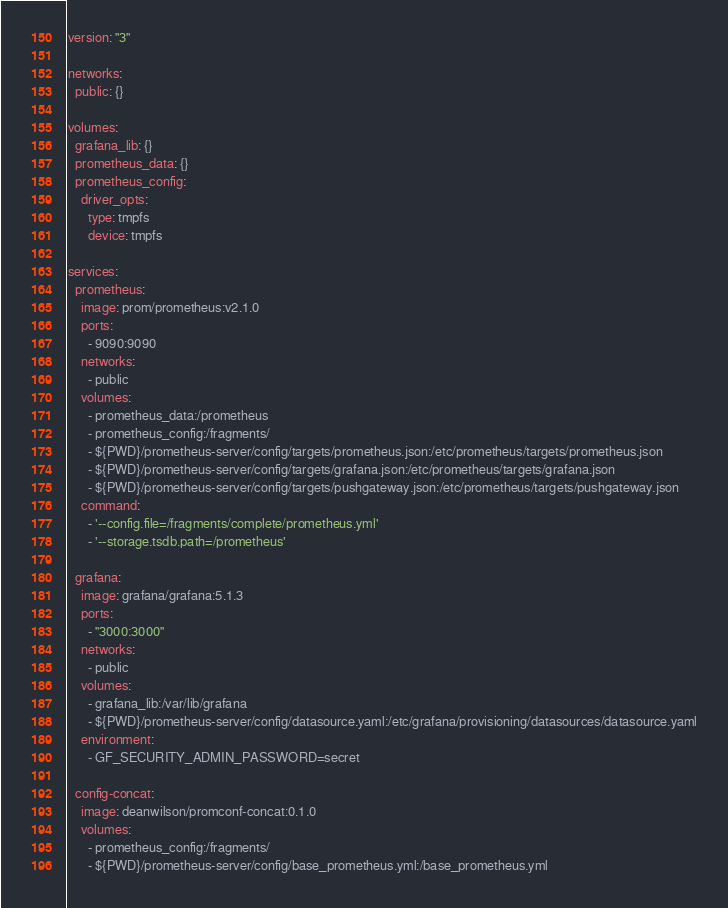<code> <loc_0><loc_0><loc_500><loc_500><_YAML_>version: "3"

networks:
  public: {}

volumes:
  grafana_lib: {}
  prometheus_data: {}
  prometheus_config:
    driver_opts:
      type: tmpfs
      device: tmpfs

services:
  prometheus:
    image: prom/prometheus:v2.1.0
    ports:
      - 9090:9090
    networks:
      - public
    volumes:
      - prometheus_data:/prometheus
      - prometheus_config:/fragments/
      - ${PWD}/prometheus-server/config/targets/prometheus.json:/etc/prometheus/targets/prometheus.json
      - ${PWD}/prometheus-server/config/targets/grafana.json:/etc/prometheus/targets/grafana.json
      - ${PWD}/prometheus-server/config/targets/pushgateway.json:/etc/prometheus/targets/pushgateway.json
    command:
      - '--config.file=/fragments/complete/prometheus.yml'
      - '--storage.tsdb.path=/prometheus'

  grafana:
    image: grafana/grafana:5.1.3
    ports:
      - "3000:3000"
    networks:
      - public
    volumes:
      - grafana_lib:/var/lib/grafana
      - ${PWD}/prometheus-server/config/datasource.yaml:/etc/grafana/provisioning/datasources/datasource.yaml
    environment:
      - GF_SECURITY_ADMIN_PASSWORD=secret

  config-concat:
    image: deanwilson/promconf-concat:0.1.0
    volumes:
      - prometheus_config:/fragments/
      - ${PWD}/prometheus-server/config/base_prometheus.yml:/base_prometheus.yml
</code> 